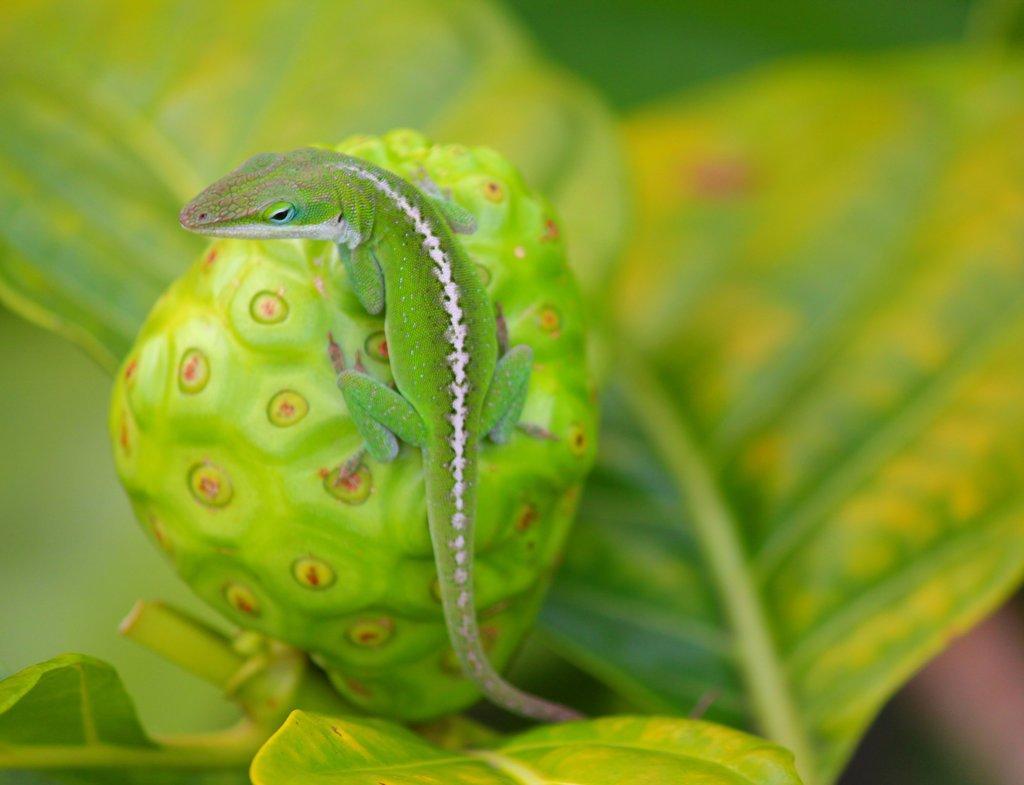Describe this image in one or two sentences. In this image in the front there is a lizard on the bud of a flower which is in the front and the background is blurry. 